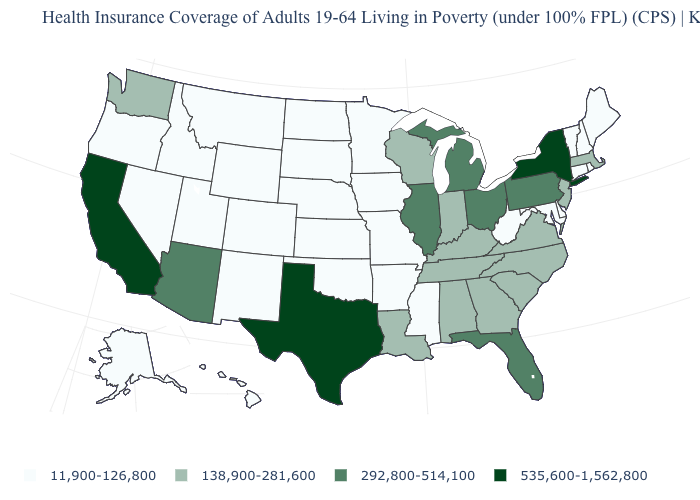How many symbols are there in the legend?
Concise answer only. 4. What is the value of Oklahoma?
Answer briefly. 11,900-126,800. Name the states that have a value in the range 138,900-281,600?
Short answer required. Alabama, Georgia, Indiana, Kentucky, Louisiana, Massachusetts, New Jersey, North Carolina, South Carolina, Tennessee, Virginia, Washington, Wisconsin. Which states have the lowest value in the USA?
Be succinct. Alaska, Arkansas, Colorado, Connecticut, Delaware, Hawaii, Idaho, Iowa, Kansas, Maine, Maryland, Minnesota, Mississippi, Missouri, Montana, Nebraska, Nevada, New Hampshire, New Mexico, North Dakota, Oklahoma, Oregon, Rhode Island, South Dakota, Utah, Vermont, West Virginia, Wyoming. Name the states that have a value in the range 138,900-281,600?
Keep it brief. Alabama, Georgia, Indiana, Kentucky, Louisiana, Massachusetts, New Jersey, North Carolina, South Carolina, Tennessee, Virginia, Washington, Wisconsin. Which states have the highest value in the USA?
Short answer required. California, New York, Texas. What is the highest value in the Northeast ?
Give a very brief answer. 535,600-1,562,800. Name the states that have a value in the range 138,900-281,600?
Give a very brief answer. Alabama, Georgia, Indiana, Kentucky, Louisiana, Massachusetts, New Jersey, North Carolina, South Carolina, Tennessee, Virginia, Washington, Wisconsin. Among the states that border Montana , which have the highest value?
Be succinct. Idaho, North Dakota, South Dakota, Wyoming. What is the value of New York?
Answer briefly. 535,600-1,562,800. Name the states that have a value in the range 535,600-1,562,800?
Be succinct. California, New York, Texas. What is the value of Utah?
Short answer required. 11,900-126,800. What is the highest value in the USA?
Be succinct. 535,600-1,562,800. Is the legend a continuous bar?
Short answer required. No. What is the lowest value in the USA?
Be succinct. 11,900-126,800. 